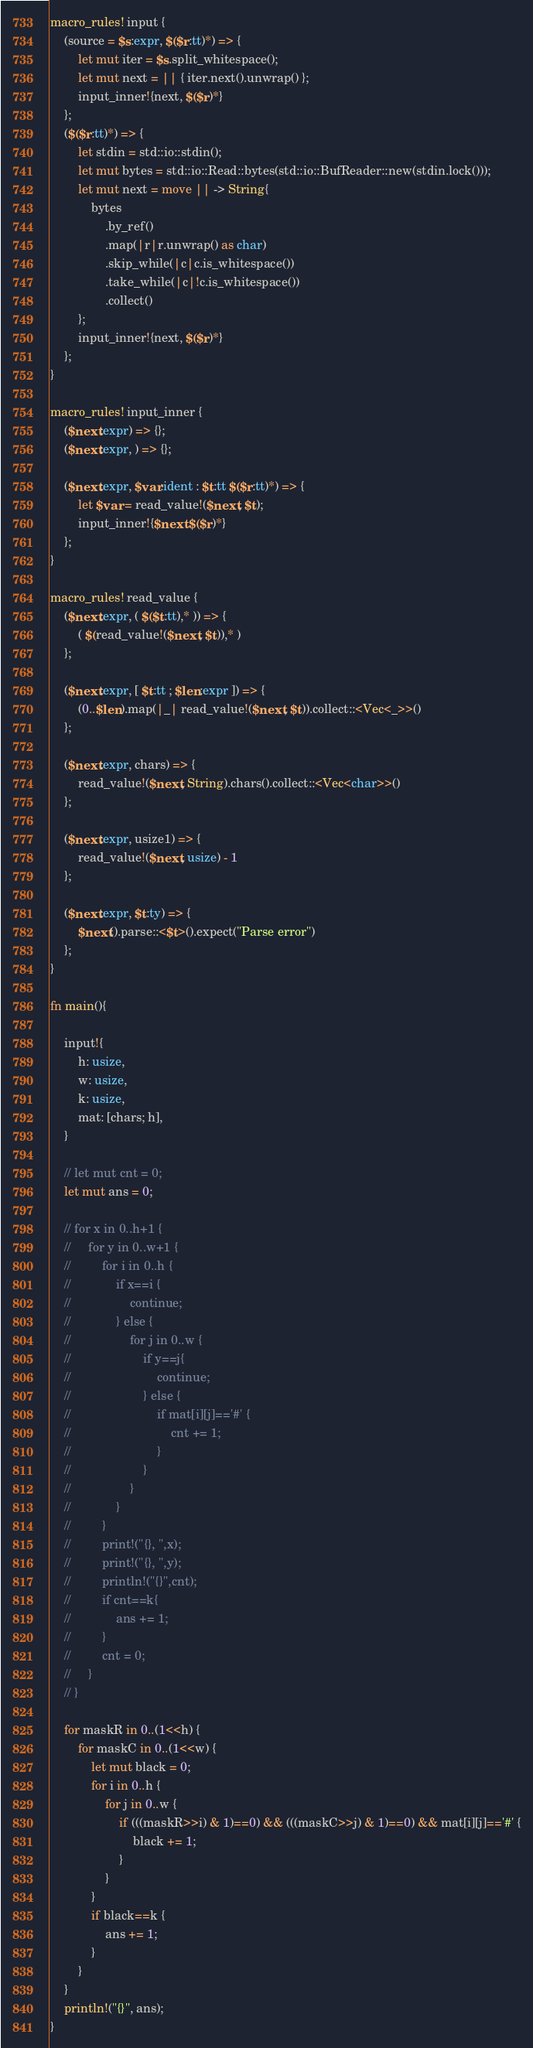Convert code to text. <code><loc_0><loc_0><loc_500><loc_500><_Rust_>macro_rules! input {
    (source = $s:expr, $($r:tt)*) => {
        let mut iter = $s.split_whitespace();
        let mut next = || { iter.next().unwrap() };
        input_inner!{next, $($r)*}
    };
    ($($r:tt)*) => {
        let stdin = std::io::stdin();
        let mut bytes = std::io::Read::bytes(std::io::BufReader::new(stdin.lock()));
        let mut next = move || -> String{
            bytes
                .by_ref()
                .map(|r|r.unwrap() as char)
                .skip_while(|c|c.is_whitespace())
                .take_while(|c|!c.is_whitespace())
                .collect()
        };
        input_inner!{next, $($r)*}
    };
}

macro_rules! input_inner {
    ($next:expr) => {};
    ($next:expr, ) => {};

    ($next:expr, $var:ident : $t:tt $($r:tt)*) => {
        let $var = read_value!($next, $t);
        input_inner!{$next $($r)*}
    };
}

macro_rules! read_value {
    ($next:expr, ( $($t:tt),* )) => {
        ( $(read_value!($next, $t)),* )
    };

    ($next:expr, [ $t:tt ; $len:expr ]) => {
        (0..$len).map(|_| read_value!($next, $t)).collect::<Vec<_>>()
    };

    ($next:expr, chars) => {
        read_value!($next, String).chars().collect::<Vec<char>>()
    };

    ($next:expr, usize1) => {
        read_value!($next, usize) - 1
    };

    ($next:expr, $t:ty) => {
        $next().parse::<$t>().expect("Parse error")
    };
}

fn main(){

    input!{
        h: usize,
        w: usize,
        k: usize,
        mat: [chars; h],
    }

    // let mut cnt = 0;
    let mut ans = 0;

    // for x in 0..h+1 {
    //     for y in 0..w+1 {
    //         for i in 0..h {
    //             if x==i {
    //                 continue;
    //             } else {
    //                 for j in 0..w {
    //                     if y==j{
    //                         continue;
    //                     } else {
    //                         if mat[i][j]=='#' {
    //                             cnt += 1;
    //                         }
    //                     }
    //                 }
    //             }
    //         }
    //         print!("{}, ",x);
    //         print!("{}, ",y);
    //         println!("{}",cnt);
    //         if cnt==k{
    //             ans += 1;
    //         }
    //         cnt = 0;
    //     }
    // }
    
    for maskR in 0..(1<<h) {
        for maskC in 0..(1<<w) {
            let mut black = 0;
            for i in 0..h {
                for j in 0..w {
                    if (((maskR>>i) & 1)==0) && (((maskC>>j) & 1)==0) && mat[i][j]=='#' {
                        black += 1;
                    }
                }
            }
            if black==k {
                ans += 1;
            }
        }
    }
    println!("{}", ans);
}</code> 